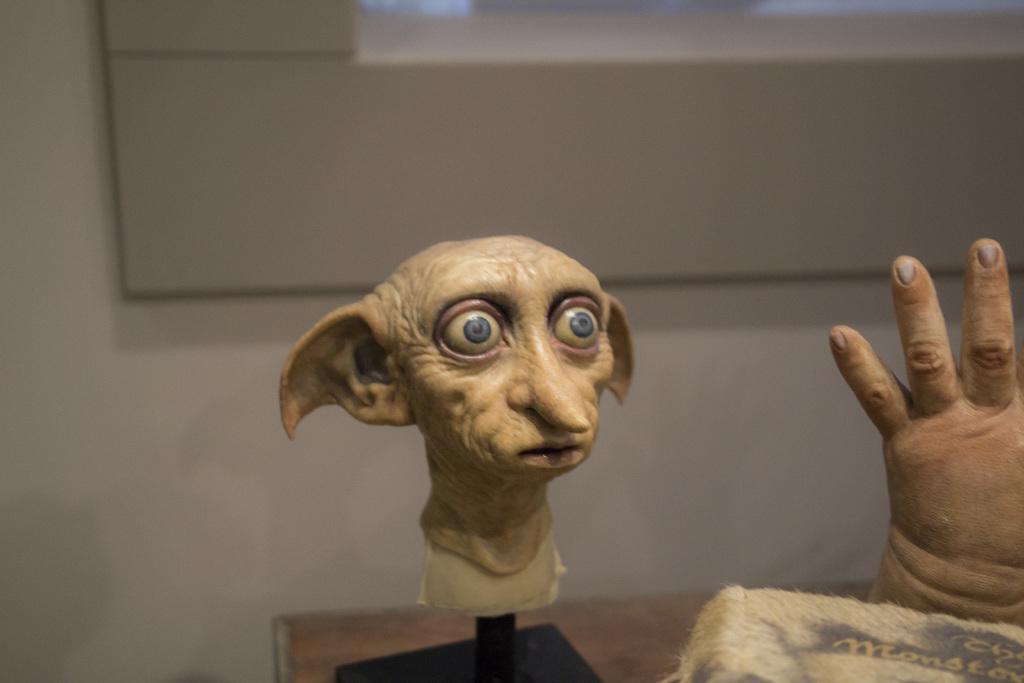How would you summarize this image in a sentence or two? In this image we can see the face mask on the stand. Beside that there is a hand mask on the table. In front of the image there is some object. In the background of the image there is a wall. There is a screen. 